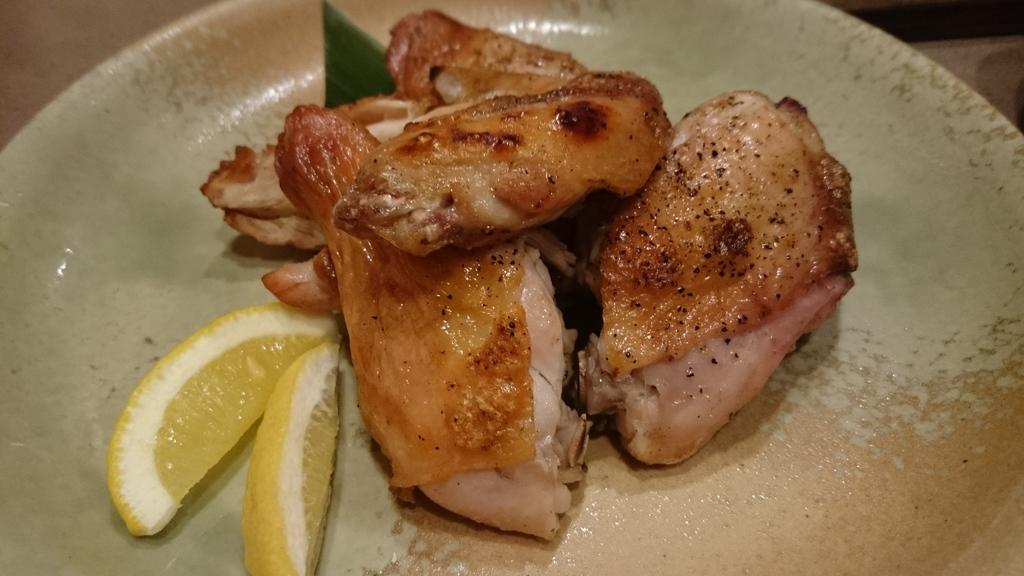What is on the plate that is visible in the image? The plate contains lemon and meat slices. What type of fruit is on the plate? The fruit on the plate is lemon. What type of food is on the plate besides the fruit? The plate contains meat slices. What type of leather is visible on the plate in the image? There is no leather present on the plate in the image. What type of magic is being performed with the lemon and meat slices in the image? There is no magic being performed in the image; it simply shows a plate with lemon and meat slices. 